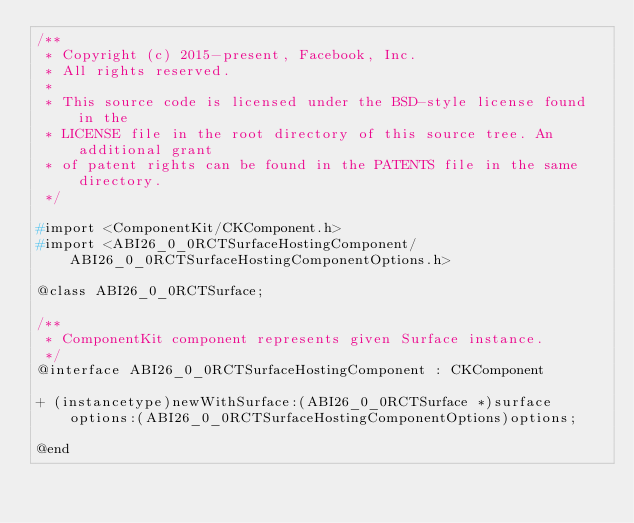Convert code to text. <code><loc_0><loc_0><loc_500><loc_500><_C_>/**
 * Copyright (c) 2015-present, Facebook, Inc.
 * All rights reserved.
 *
 * This source code is licensed under the BSD-style license found in the
 * LICENSE file in the root directory of this source tree. An additional grant
 * of patent rights can be found in the PATENTS file in the same directory.
 */

#import <ComponentKit/CKComponent.h>
#import <ABI26_0_0RCTSurfaceHostingComponent/ABI26_0_0RCTSurfaceHostingComponentOptions.h>

@class ABI26_0_0RCTSurface;

/**
 * ComponentKit component represents given Surface instance.
 */
@interface ABI26_0_0RCTSurfaceHostingComponent : CKComponent

+ (instancetype)newWithSurface:(ABI26_0_0RCTSurface *)surface options:(ABI26_0_0RCTSurfaceHostingComponentOptions)options;

@end
</code> 